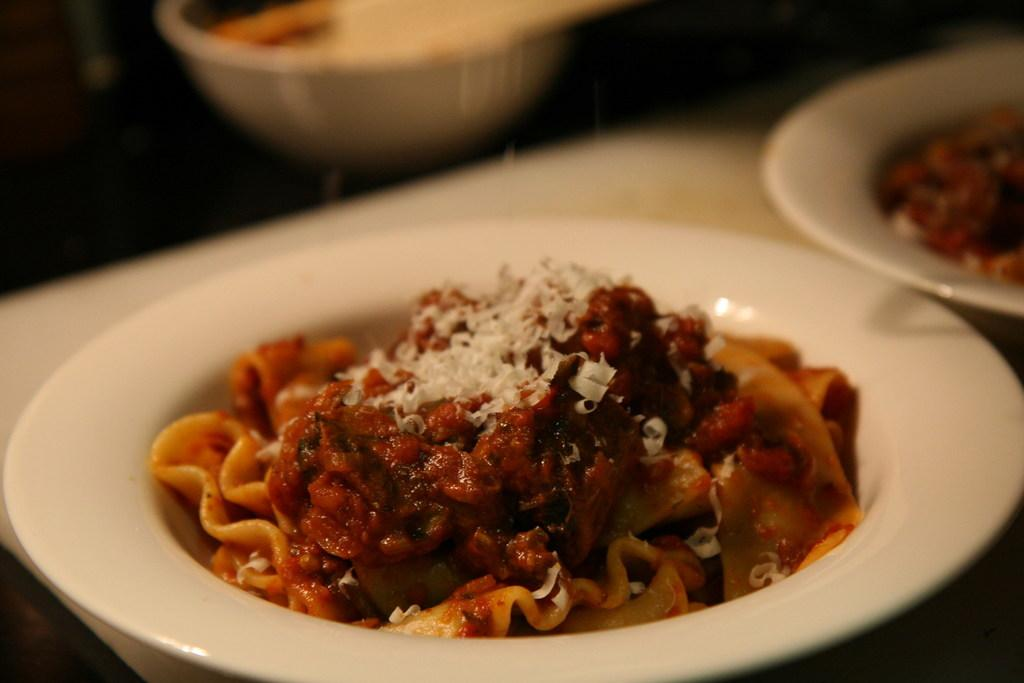What type of food can be seen in the image? There is food in the image, but the specific type cannot be determined from the provided facts. What is present on the table in the image? There are plates and a bowl on the table in the image. What type of flower is blooming on the table in the image? There is no flower present on the table in the image. What month is it in the image? The month cannot be determined from the image or the provided facts. 